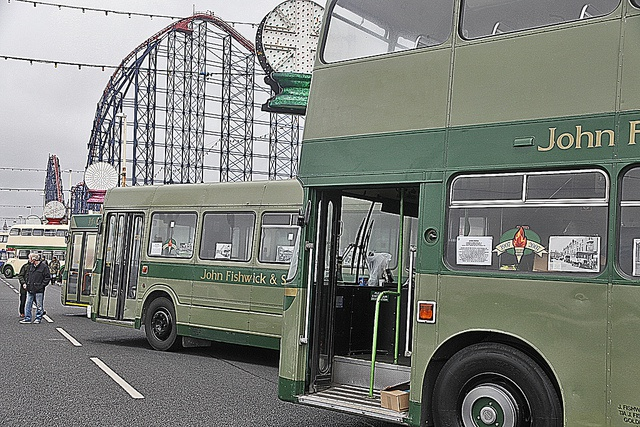Describe the objects in this image and their specific colors. I can see bus in lightgray, gray, black, and darkgray tones, bus in lightgray, gray, darkgray, and black tones, bus in lightgray, ivory, darkgray, gray, and black tones, bus in lightgray, gray, darkgray, and black tones, and people in lightgray, black, gray, and darkgray tones in this image. 